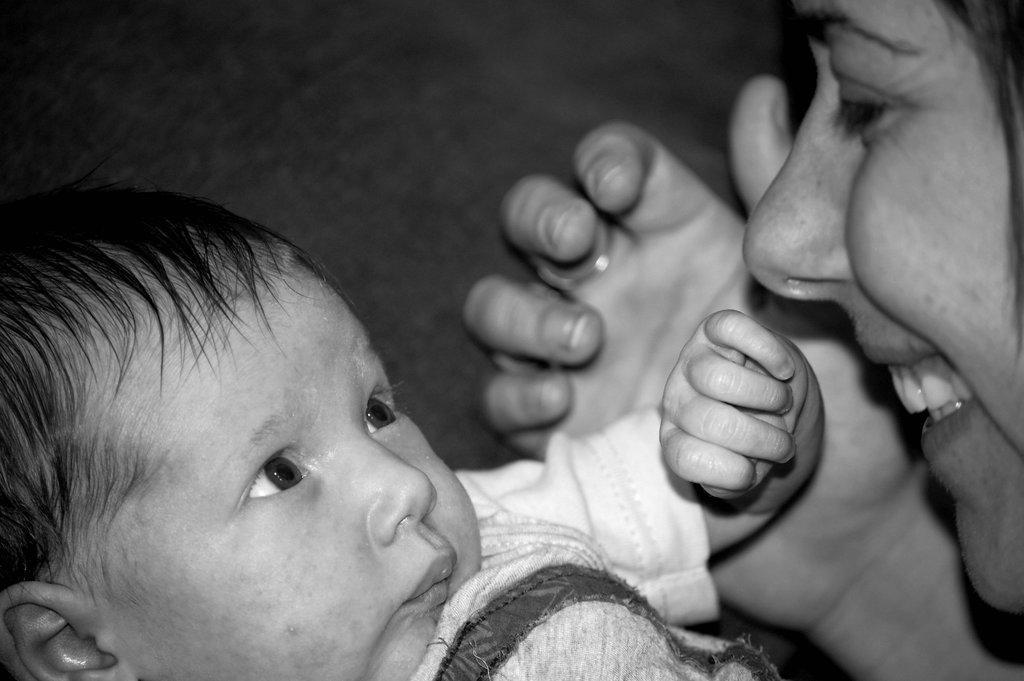Describe this image in one or two sentences. In this picture we can observe a baby. There is a woman smiling on the right side. This is a black and white image. 